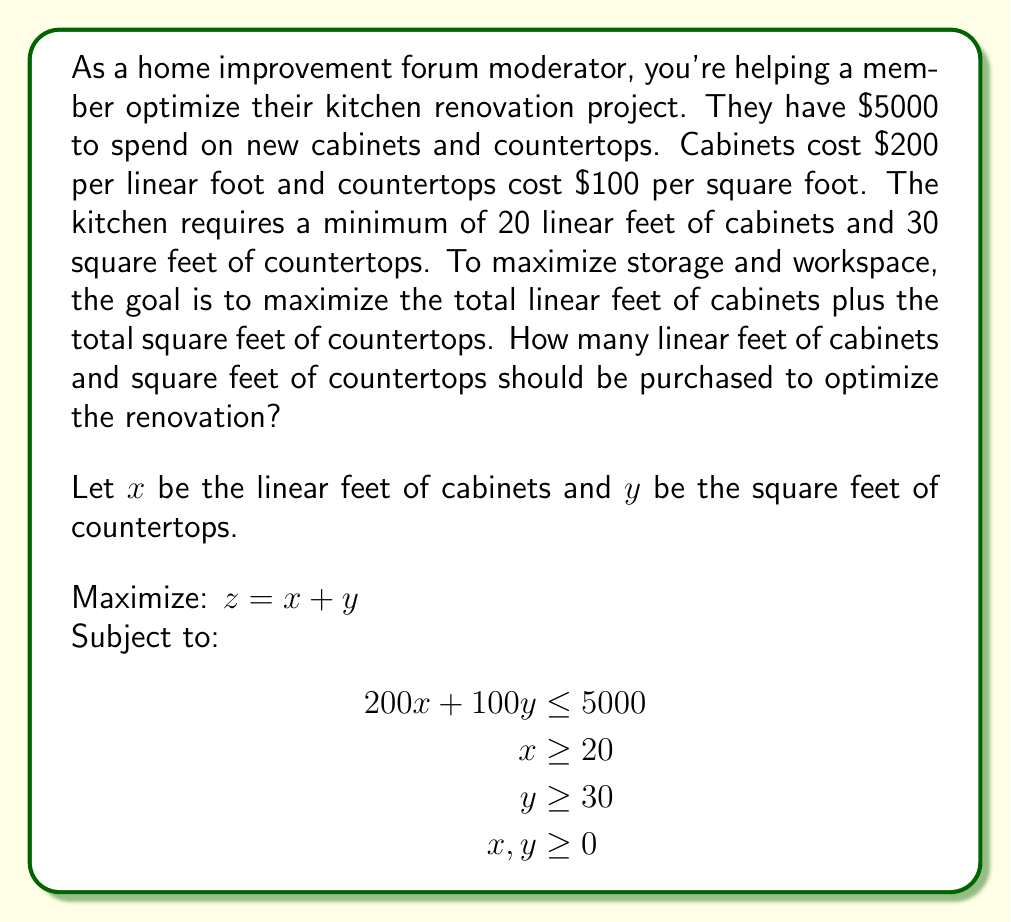Teach me how to tackle this problem. To solve this linear programming problem, we can use the graphical method:

1. Plot the constraints:
   - Budget constraint: $200x + 100y = 5000$ or $y = 50 - 2x$
   - Minimum cabinet requirement: $x = 20$
   - Minimum countertop requirement: $y = 30$

2. Identify the feasible region:
   The feasible region is the area that satisfies all constraints.

3. Find the corner points of the feasible region:
   A: (20, 30)
   B: (20, 10)
   C: (25, 0)

4. Evaluate the objective function at each corner point:
   A: $z = 20 + 30 = 50$
   B: $z = 20 + 10 = 30$
   C: $z = 25 + 0 = 25$

5. The optimal solution is the point with the highest z value, which is point A.

Therefore, the optimal solution is to purchase 20 linear feet of cabinets and 30 square feet of countertops.

To verify:
- Cost: $200(20) + 100(30) = 4000 + 3000 = 7000$, which is within the budget.
- Cabinets: 20 linear feet (meets minimum requirement)
- Countertops: 30 square feet (meets minimum requirement)
- Total value: $20 + 30 = 50$ (maximized)
Answer: The optimal solution is to purchase 20 linear feet of cabinets and 30 square feet of countertops. 